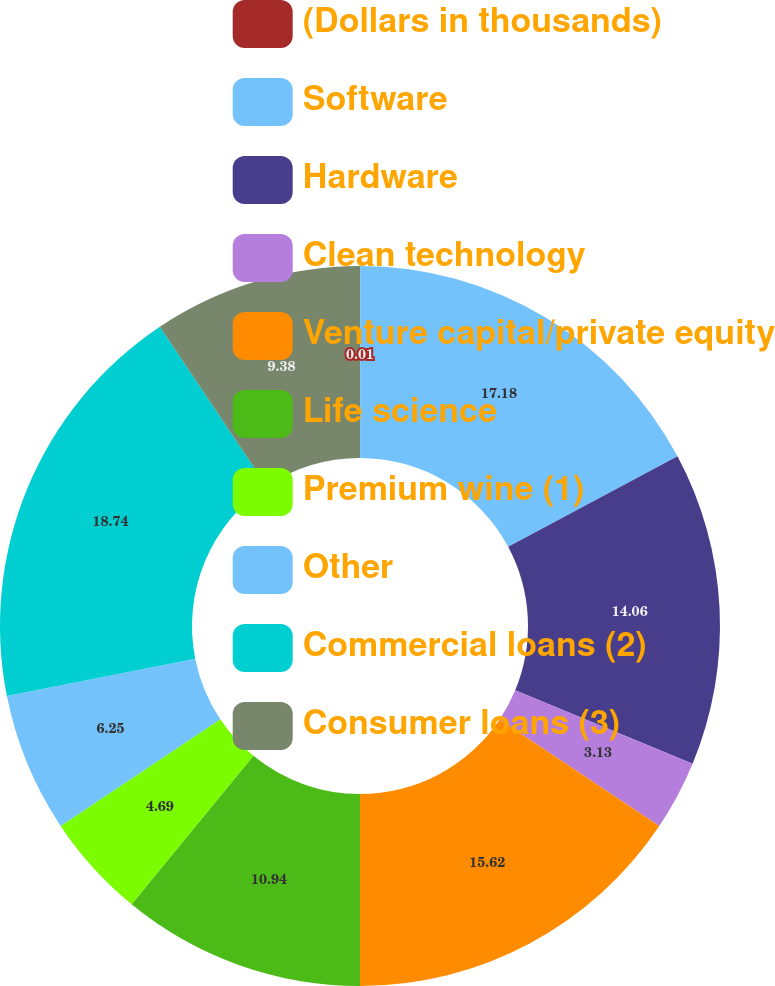Convert chart. <chart><loc_0><loc_0><loc_500><loc_500><pie_chart><fcel>(Dollars in thousands)<fcel>Software<fcel>Hardware<fcel>Clean technology<fcel>Venture capital/private equity<fcel>Life science<fcel>Premium wine (1)<fcel>Other<fcel>Commercial loans (2)<fcel>Consumer loans (3)<nl><fcel>0.01%<fcel>17.18%<fcel>14.06%<fcel>3.13%<fcel>15.62%<fcel>10.94%<fcel>4.69%<fcel>6.25%<fcel>18.74%<fcel>9.38%<nl></chart> 